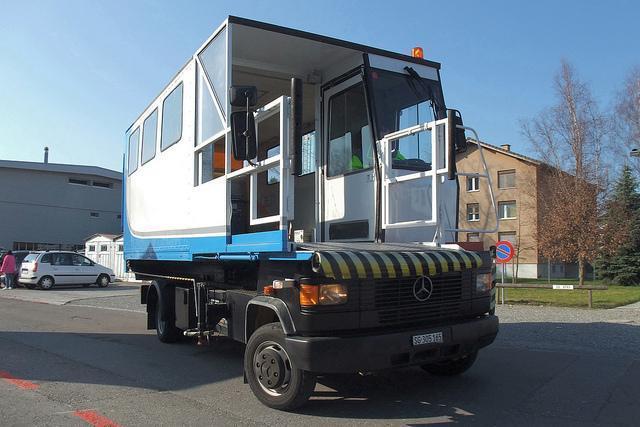How many people are visible behind the car?
Give a very brief answer. 1. How many cylinders does this truck likely have?
Give a very brief answer. 6. How many people are in the photo?
Give a very brief answer. 0. How many trucks are there?
Give a very brief answer. 1. 